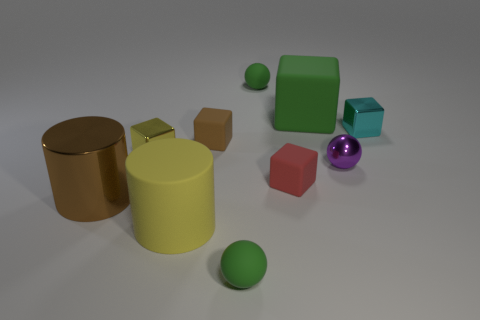Subtract 1 balls. How many balls are left? 2 Subtract all red cubes. How many cubes are left? 4 Subtract all large matte cubes. How many cubes are left? 4 Subtract all purple cubes. Subtract all yellow cylinders. How many cubes are left? 5 Subtract all large brown things. Subtract all large yellow rubber things. How many objects are left? 8 Add 7 tiny cyan blocks. How many tiny cyan blocks are left? 8 Add 2 large green rubber things. How many large green rubber things exist? 3 Subtract 1 yellow cubes. How many objects are left? 9 Subtract all cylinders. How many objects are left? 8 